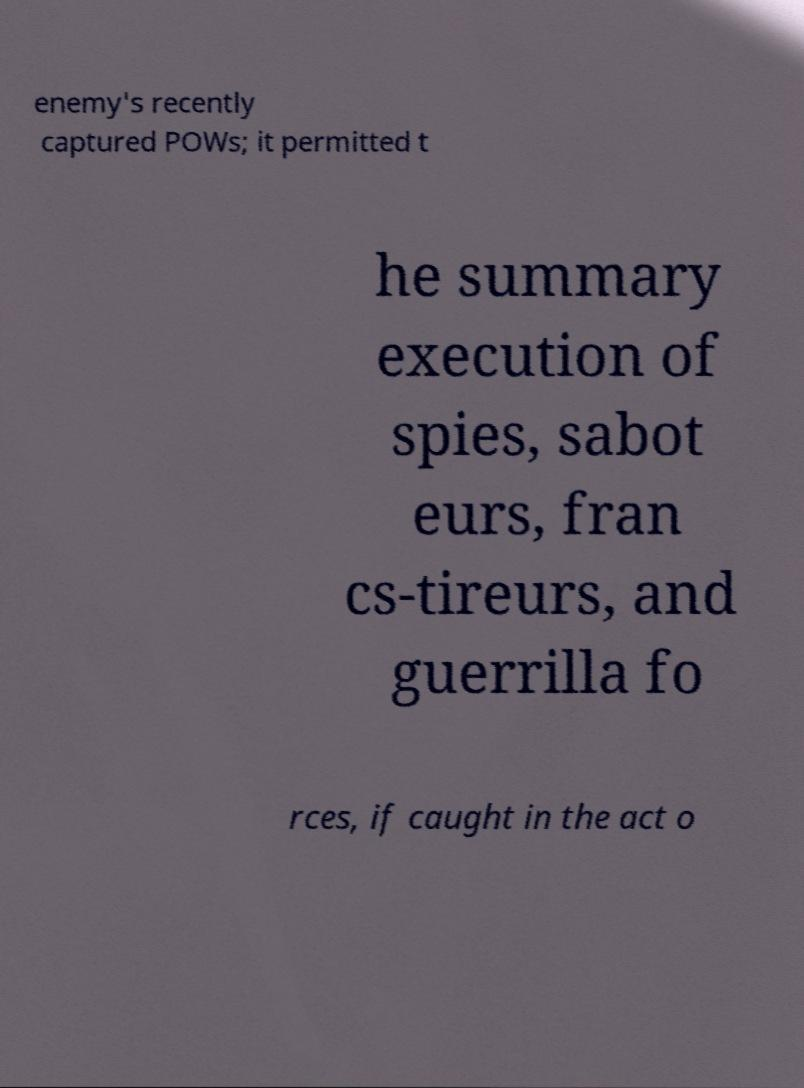There's text embedded in this image that I need extracted. Can you transcribe it verbatim? enemy's recently captured POWs; it permitted t he summary execution of spies, sabot eurs, fran cs-tireurs, and guerrilla fo rces, if caught in the act o 